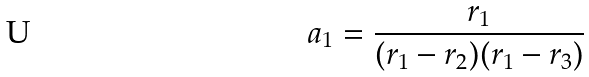Convert formula to latex. <formula><loc_0><loc_0><loc_500><loc_500>a _ { 1 } = \frac { r _ { 1 } } { ( r _ { 1 } - r _ { 2 } ) ( r _ { 1 } - r _ { 3 } ) }</formula> 